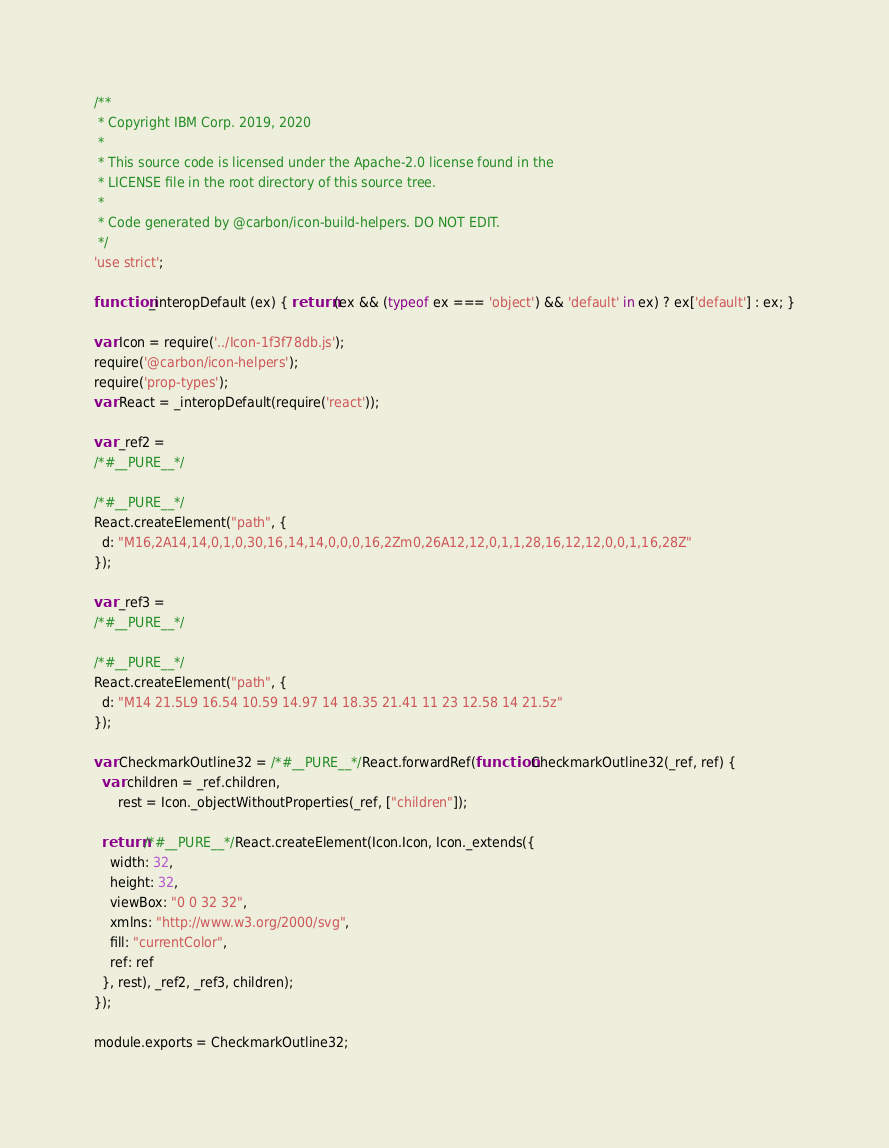<code> <loc_0><loc_0><loc_500><loc_500><_JavaScript_>/**
 * Copyright IBM Corp. 2019, 2020
 *
 * This source code is licensed under the Apache-2.0 license found in the
 * LICENSE file in the root directory of this source tree.
 *
 * Code generated by @carbon/icon-build-helpers. DO NOT EDIT.
 */
'use strict';

function _interopDefault (ex) { return (ex && (typeof ex === 'object') && 'default' in ex) ? ex['default'] : ex; }

var Icon = require('../Icon-1f3f78db.js');
require('@carbon/icon-helpers');
require('prop-types');
var React = _interopDefault(require('react'));

var _ref2 =
/*#__PURE__*/

/*#__PURE__*/
React.createElement("path", {
  d: "M16,2A14,14,0,1,0,30,16,14,14,0,0,0,16,2Zm0,26A12,12,0,1,1,28,16,12,12,0,0,1,16,28Z"
});

var _ref3 =
/*#__PURE__*/

/*#__PURE__*/
React.createElement("path", {
  d: "M14 21.5L9 16.54 10.59 14.97 14 18.35 21.41 11 23 12.58 14 21.5z"
});

var CheckmarkOutline32 = /*#__PURE__*/React.forwardRef(function CheckmarkOutline32(_ref, ref) {
  var children = _ref.children,
      rest = Icon._objectWithoutProperties(_ref, ["children"]);

  return /*#__PURE__*/React.createElement(Icon.Icon, Icon._extends({
    width: 32,
    height: 32,
    viewBox: "0 0 32 32",
    xmlns: "http://www.w3.org/2000/svg",
    fill: "currentColor",
    ref: ref
  }, rest), _ref2, _ref3, children);
});

module.exports = CheckmarkOutline32;
</code> 